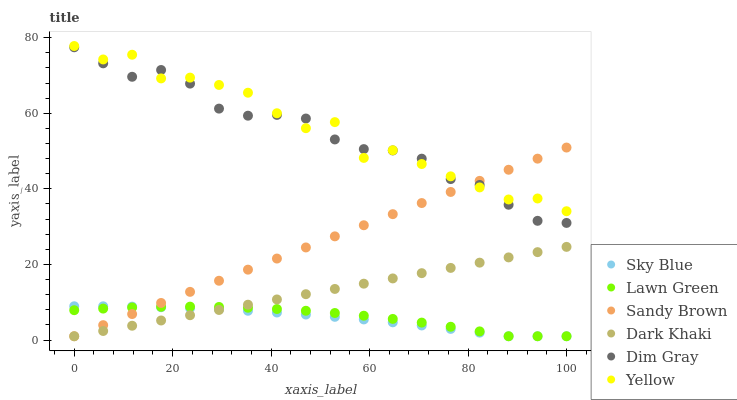Does Sky Blue have the minimum area under the curve?
Answer yes or no. Yes. Does Yellow have the maximum area under the curve?
Answer yes or no. Yes. Does Dim Gray have the minimum area under the curve?
Answer yes or no. No. Does Dim Gray have the maximum area under the curve?
Answer yes or no. No. Is Dark Khaki the smoothest?
Answer yes or no. Yes. Is Yellow the roughest?
Answer yes or no. Yes. Is Dim Gray the smoothest?
Answer yes or no. No. Is Dim Gray the roughest?
Answer yes or no. No. Does Lawn Green have the lowest value?
Answer yes or no. Yes. Does Dim Gray have the lowest value?
Answer yes or no. No. Does Yellow have the highest value?
Answer yes or no. Yes. Does Dim Gray have the highest value?
Answer yes or no. No. Is Lawn Green less than Yellow?
Answer yes or no. Yes. Is Dim Gray greater than Lawn Green?
Answer yes or no. Yes. Does Yellow intersect Dim Gray?
Answer yes or no. Yes. Is Yellow less than Dim Gray?
Answer yes or no. No. Is Yellow greater than Dim Gray?
Answer yes or no. No. Does Lawn Green intersect Yellow?
Answer yes or no. No. 